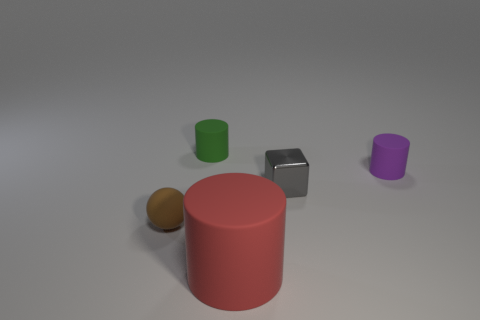Subtract all blue cylinders. Subtract all cyan balls. How many cylinders are left? 3 Add 4 big yellow cubes. How many objects exist? 9 Subtract all cubes. How many objects are left? 4 Subtract 0 gray balls. How many objects are left? 5 Subtract all red rubber cylinders. Subtract all small purple things. How many objects are left? 3 Add 4 large matte objects. How many large matte objects are left? 5 Add 3 green cylinders. How many green cylinders exist? 4 